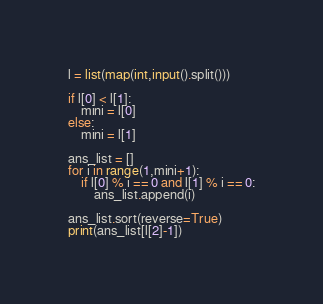<code> <loc_0><loc_0><loc_500><loc_500><_Python_>l = list(map(int,input().split()))

if l[0] < l[1]:
    mini = l[0]
else:
    mini = l[1]

ans_list = []
for i in range(1,mini+1):
    if l[0] % i == 0 and l[1] % i == 0:
        ans_list.append(i)

ans_list.sort(reverse=True)
print(ans_list[l[2]-1])</code> 